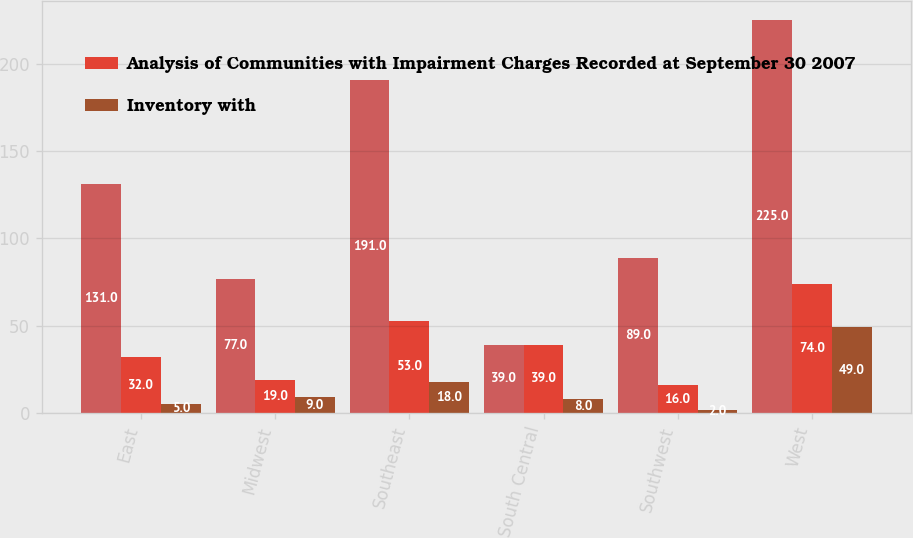Convert chart. <chart><loc_0><loc_0><loc_500><loc_500><stacked_bar_chart><ecel><fcel>East<fcel>Midwest<fcel>Southeast<fcel>South Central<fcel>Southwest<fcel>West<nl><fcel>nan<fcel>131<fcel>77<fcel>191<fcel>39<fcel>89<fcel>225<nl><fcel>Analysis of Communities with Impairment Charges Recorded at September 30 2007<fcel>32<fcel>19<fcel>53<fcel>39<fcel>16<fcel>74<nl><fcel>Inventory with<fcel>5<fcel>9<fcel>18<fcel>8<fcel>2<fcel>49<nl></chart> 